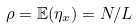<formula> <loc_0><loc_0><loc_500><loc_500>\rho = \mathbb { E } ( \eta _ { x } ) = N / L</formula> 